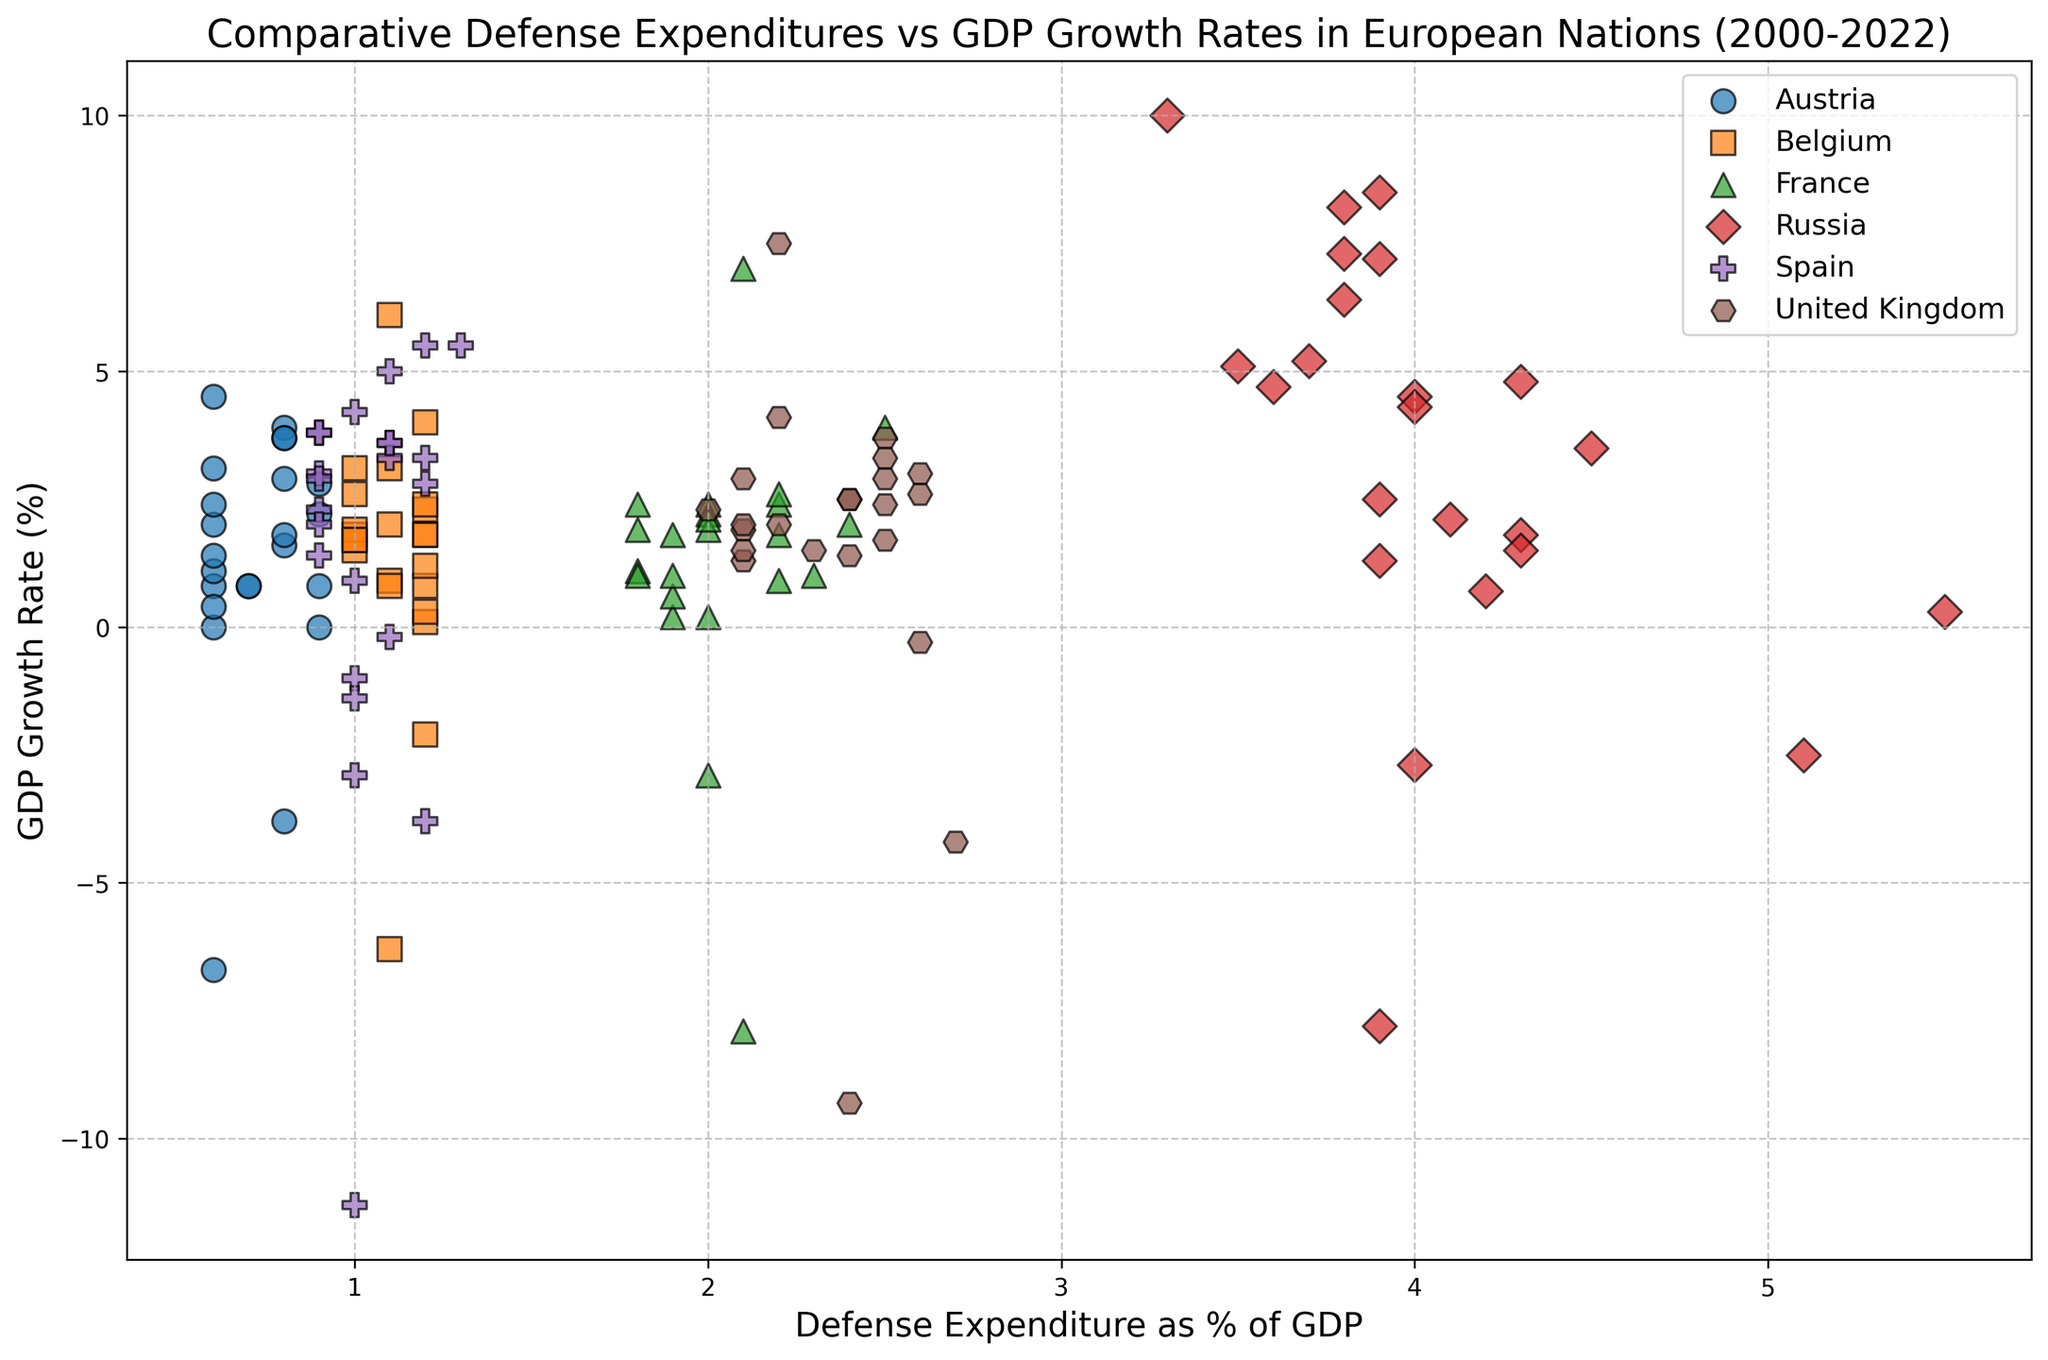What is the general trend between defense expenditure as a % of GDP and GDP growth rate for Russia? Observing the scatter plot for Russia’s data points, we can see that despite some fluctuations, higher defense expenditures tend to correlate with periods of varied GDP growth rates, including both high growth and negative growth periods. Russia has relatively high defense expenditures compared to other countries.
Answer: Varied trend with both positive and negative GDP growth rates Which country has the highest defense expenditure as a % of GDP in 2022? Looking at the scatter plot and comparing the data points for 2022, Russia has the highest defense expenditure as a % of GDP, which is around 4.1%.
Answer: Russia Between 2020 and 2021, which countries experienced a significant increase in GDP growth rate while maintaining stable or increased defense expenditure as a % of GDP? By focusing on the data points for 2020 and 2021 and their corresponding values, Belgium, France, and the United Kingdom showed significant GDP growth rate increases while maintaining or slightly increasing their defense expenditures.
Answer: Belgium, France, United Kingdom How do Spain and Austria compare in terms of defense expenditure as a % of GDP in 2010 and GDP growth rates? Spain had a defense expenditure around 1.1% and a GDP growth rate of -0.2% in 2010. Austria had a defense expenditure around 0.8% with a GDP growth rate of 1.8% in 2010. Thus, Spain had higher defense expenditure but negative GDP growth, while Austria had lower defense expenditure and positive GDP growth.
Answer: Spain: 1.1% expenditure, -0.2% growth, Austria: 0.8% expenditure, 1.8% growth Which country shows the most consistent defense expenditure as a % of GDP over the years? Looking at the scatter plot, Austria’s data points show the least variation in defense expenditure, consistently around 0.6-0.9% across the years.
Answer: Austria During economic downturns, such as negative GDP growth rates, how do different countries' defense expenditures compare? Observing data points with negative GDP growth rates (such as 2009 and 2020), it is apparent that countries like Russia and the United Kingdom maintain higher defense expenditures compared to countries like Austria and Spain, which have relatively lower expenditures.
Answer: Russia and United Kingdom maintain higher expenditures What is the relationship between Belgium's defense expenditure and GDP growth rate over the period 2000-2022? Belgium’s defense expenditure is generally steady at around 1-1.2%. Despite this steadiness, its GDP growth rate fluctuated significantly, indicating no clear direct relationship between defense expenditure and GDP growth rate.
Answer: No clear direct relationship How did the defense expenditure as a % of GDP compare between France and the United Kingdom in 2022, and which had a higher GDP growth rate? In 2022, France’s defense expenditure was around 2.2% and the United Kingdom's was also around 2.2%. However, the United Kingdom had a higher GDP growth rate of 4.1% compared to France's 2.6%.
Answer: Both had similar expenditures, but the United Kingdom had a higher GDP growth rate Between 2015 and 2018, which country's defense expenditure showed the greatest increase, and what was the impact on its GDP growth rate? Russia showed the most considerable increase in defense expenditure, from around 5.1% to 4.0% during this period. Its GDP growth rate improved slightly from -2.5% in 2015 to 2.5% in 2018.
Answer: Russia showed the greatest increase, with a slight improvement in GDP growth Can you identify a country that had a high defense expenditure but experienced negative GDP growth in a given year? Russia in 2009 had a defense expenditure around 3.9% of GDP but experienced a negative GDP growth rate of -7.8%.
Answer: Russia in 2009 